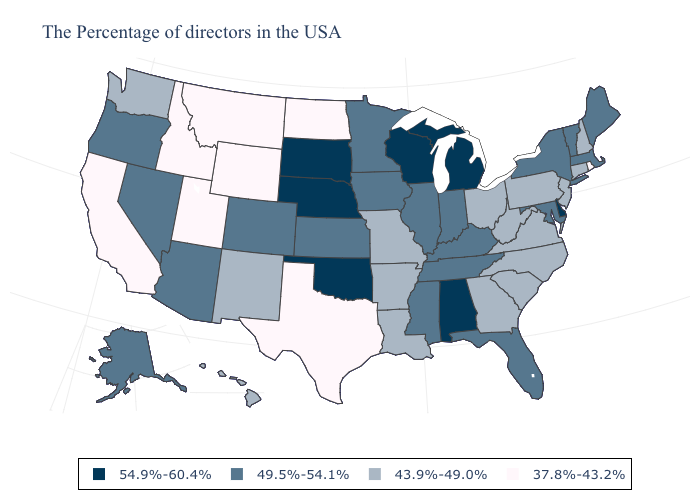What is the lowest value in the South?
Concise answer only. 37.8%-43.2%. How many symbols are there in the legend?
Concise answer only. 4. Name the states that have a value in the range 49.5%-54.1%?
Short answer required. Maine, Massachusetts, Vermont, New York, Maryland, Florida, Kentucky, Indiana, Tennessee, Illinois, Mississippi, Minnesota, Iowa, Kansas, Colorado, Arizona, Nevada, Oregon, Alaska. Among the states that border Missouri , which have the lowest value?
Short answer required. Arkansas. Does Maine have the highest value in the Northeast?
Be succinct. Yes. What is the value of Oregon?
Keep it brief. 49.5%-54.1%. How many symbols are there in the legend?
Write a very short answer. 4. Does Arizona have the same value as Montana?
Concise answer only. No. What is the value of Minnesota?
Write a very short answer. 49.5%-54.1%. Among the states that border Mississippi , which have the highest value?
Quick response, please. Alabama. Among the states that border North Dakota , which have the highest value?
Answer briefly. South Dakota. What is the lowest value in the USA?
Be succinct. 37.8%-43.2%. Does Alabama have the highest value in the USA?
Write a very short answer. Yes. What is the lowest value in states that border New Hampshire?
Give a very brief answer. 49.5%-54.1%. 